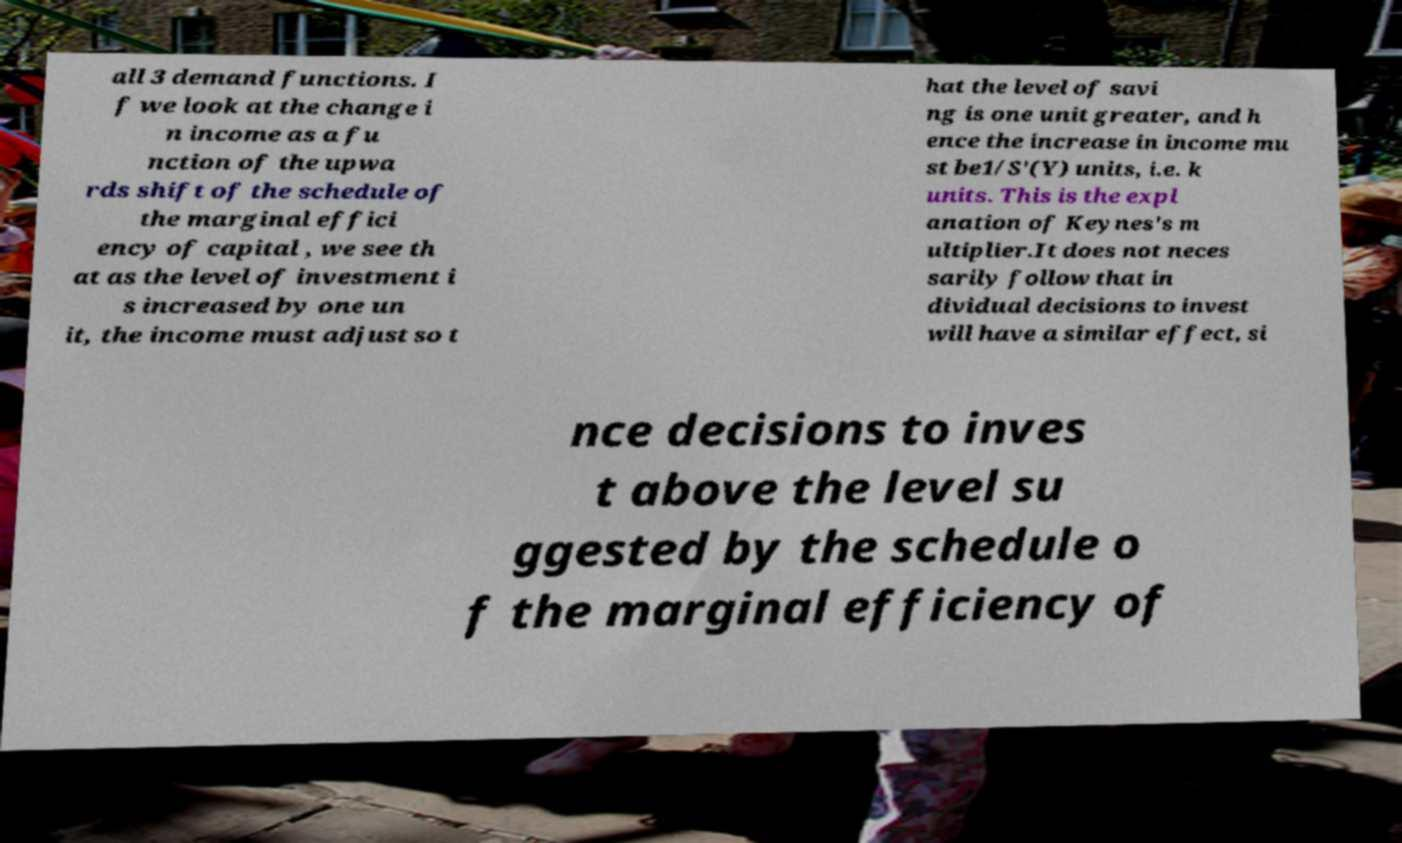For documentation purposes, I need the text within this image transcribed. Could you provide that? all 3 demand functions. I f we look at the change i n income as a fu nction of the upwa rds shift of the schedule of the marginal effici ency of capital , we see th at as the level of investment i s increased by one un it, the income must adjust so t hat the level of savi ng is one unit greater, and h ence the increase in income mu st be1/S'(Y) units, i.e. k units. This is the expl anation of Keynes's m ultiplier.It does not neces sarily follow that in dividual decisions to invest will have a similar effect, si nce decisions to inves t above the level su ggested by the schedule o f the marginal efficiency of 